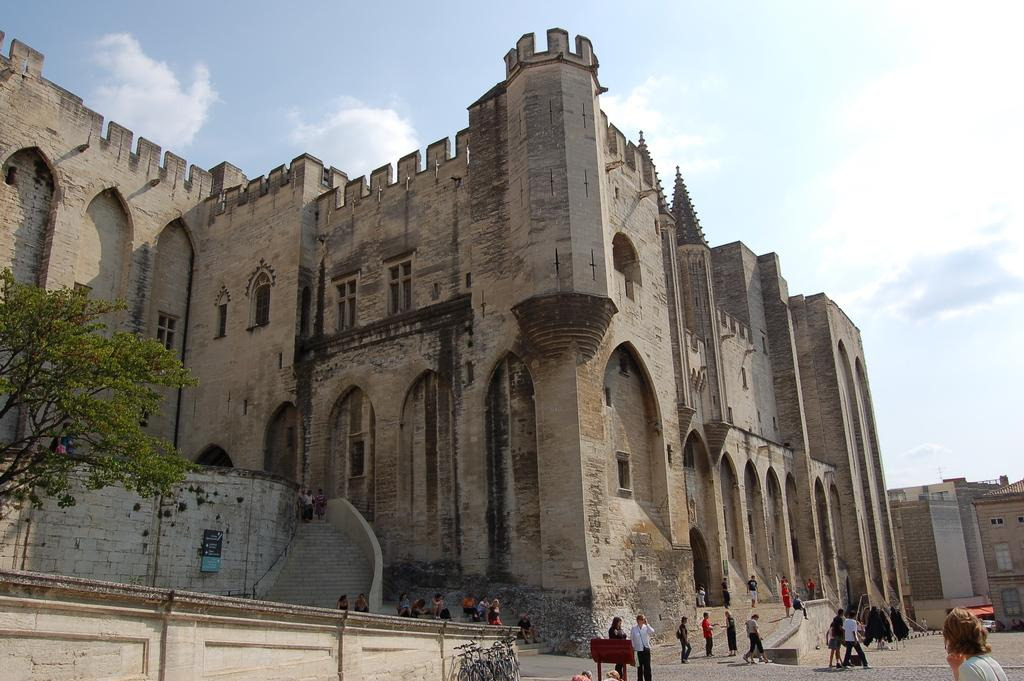What type of structure is in the image? There is a heritage building in the image. Are there any people present in the image? Yes, there are people in the image. What architectural feature can be seen in the image? There are stairs in the image. What other elements are present in the image? There are plants in the image. What can be seen in the background of the image? The sky is visible in the background of the image. What type of linen is draped over the beast in the image? There is no beast or linen present in the image. 